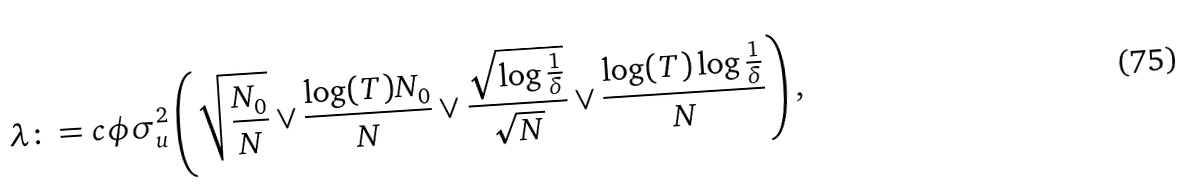Convert formula to latex. <formula><loc_0><loc_0><loc_500><loc_500>\lambda \colon = c \phi \sigma _ { u } ^ { 2 } \left ( \sqrt { \frac { N _ { 0 } } { N } } \vee \frac { \log ( T ) N _ { 0 } } { N } \vee \frac { \sqrt { \log { \frac { 1 } { \delta } } } } { \sqrt { N } } \vee \frac { \log ( T ) \log { \frac { 1 } { \delta } } } { N } \right ) ,</formula> 